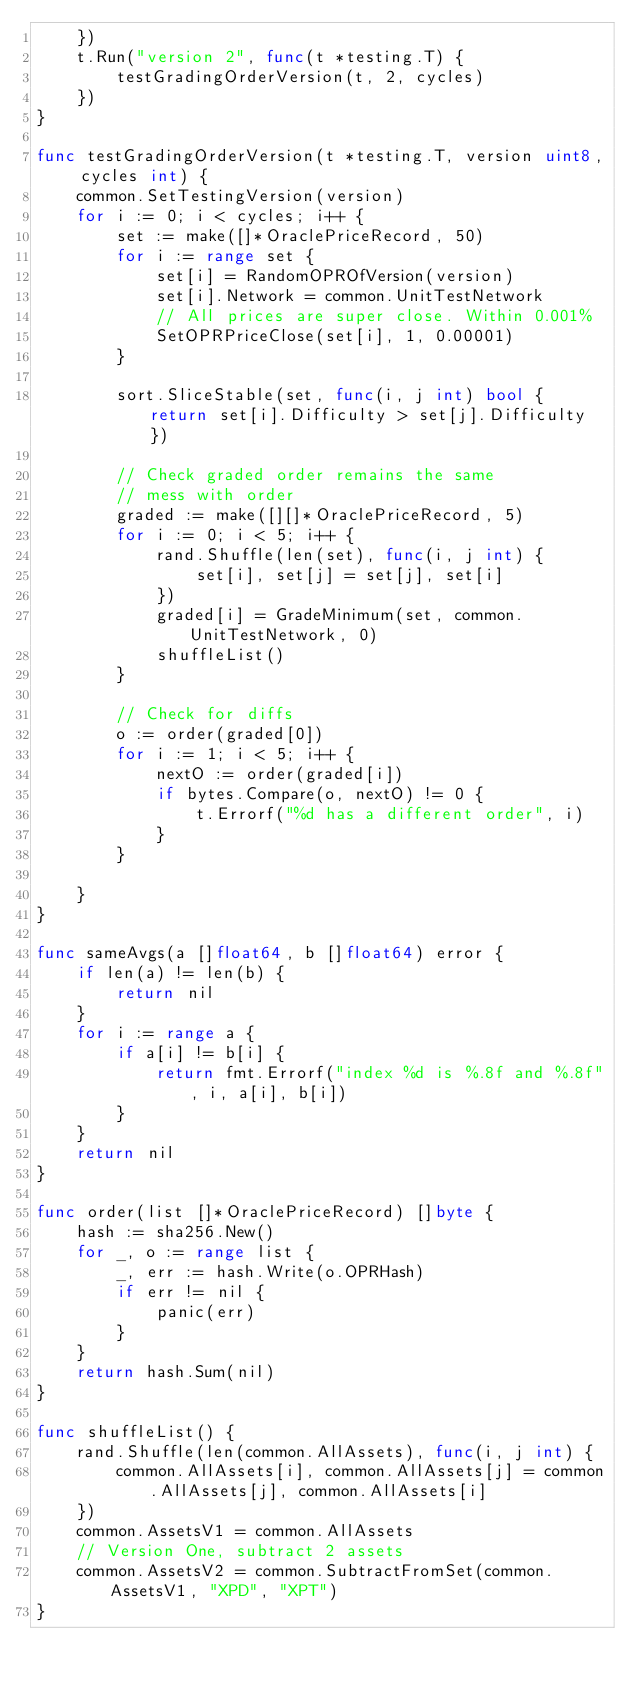Convert code to text. <code><loc_0><loc_0><loc_500><loc_500><_Go_>	})
	t.Run("version 2", func(t *testing.T) {
		testGradingOrderVersion(t, 2, cycles)
	})
}

func testGradingOrderVersion(t *testing.T, version uint8, cycles int) {
	common.SetTestingVersion(version)
	for i := 0; i < cycles; i++ {
		set := make([]*OraclePriceRecord, 50)
		for i := range set {
			set[i] = RandomOPROfVersion(version)
			set[i].Network = common.UnitTestNetwork
			// All prices are super close. Within 0.001%
			SetOPRPriceClose(set[i], 1, 0.00001)
		}

		sort.SliceStable(set, func(i, j int) bool { return set[i].Difficulty > set[j].Difficulty })

		// Check graded order remains the same
		// mess with order
		graded := make([][]*OraclePriceRecord, 5)
		for i := 0; i < 5; i++ {
			rand.Shuffle(len(set), func(i, j int) {
				set[i], set[j] = set[j], set[i]
			})
			graded[i] = GradeMinimum(set, common.UnitTestNetwork, 0)
			shuffleList()
		}

		// Check for diffs
		o := order(graded[0])
		for i := 1; i < 5; i++ {
			nextO := order(graded[i])
			if bytes.Compare(o, nextO) != 0 {
				t.Errorf("%d has a different order", i)
			}
		}

	}
}

func sameAvgs(a []float64, b []float64) error {
	if len(a) != len(b) {
		return nil
	}
	for i := range a {
		if a[i] != b[i] {
			return fmt.Errorf("index %d is %.8f and %.8f", i, a[i], b[i])
		}
	}
	return nil
}

func order(list []*OraclePriceRecord) []byte {
	hash := sha256.New()
	for _, o := range list {
		_, err := hash.Write(o.OPRHash)
		if err != nil {
			panic(err)
		}
	}
	return hash.Sum(nil)
}

func shuffleList() {
	rand.Shuffle(len(common.AllAssets), func(i, j int) {
		common.AllAssets[i], common.AllAssets[j] = common.AllAssets[j], common.AllAssets[i]
	})
	common.AssetsV1 = common.AllAssets
	// Version One, subtract 2 assets
	common.AssetsV2 = common.SubtractFromSet(common.AssetsV1, "XPD", "XPT")
}
</code> 